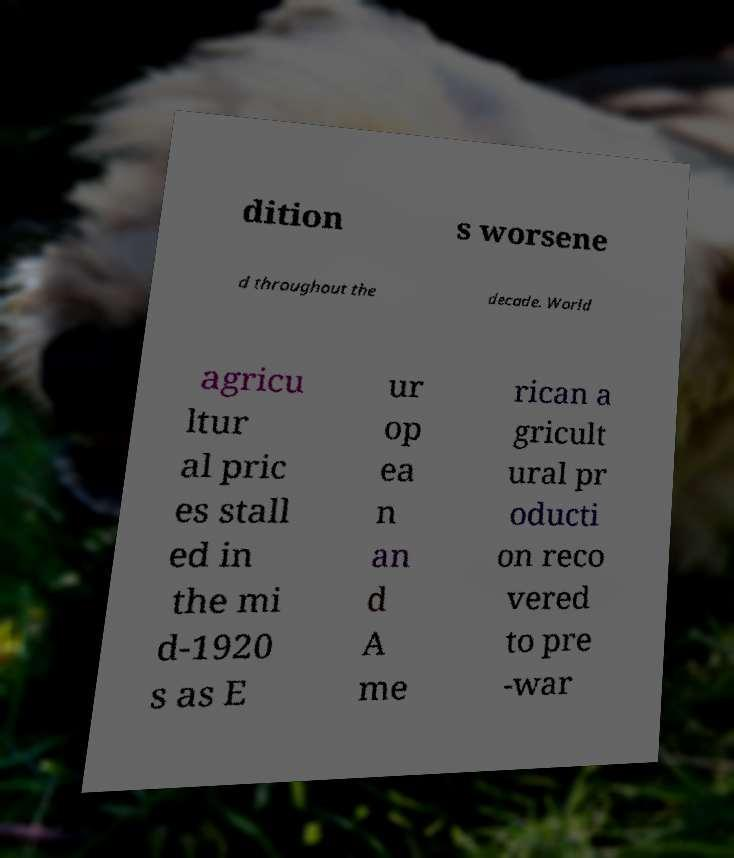Please read and relay the text visible in this image. What does it say? dition s worsene d throughout the decade. World agricu ltur al pric es stall ed in the mi d-1920 s as E ur op ea n an d A me rican a gricult ural pr oducti on reco vered to pre -war 